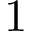<formula> <loc_0><loc_0><loc_500><loc_500>1</formula> 